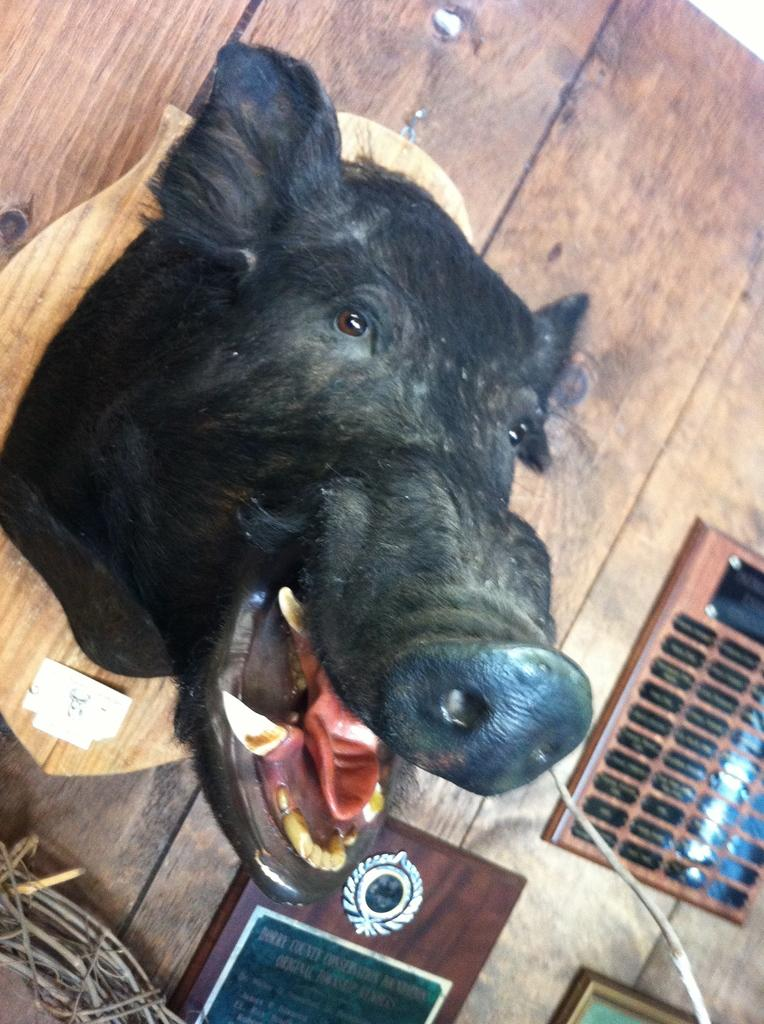What is the main subject of the image? The main subject of the image is a statue of a boar's head. Where is the statue placed in the image? The statue is kept on a wooden wall. What other object can be seen in the image? There is a shield in the image. How is the shield positioned in the image? The shield is kept on the ground. What type of pan is hanging from the boar's head in the image? There is no pan present in the image; it features a statue of a boar's head and a shield. Can you see any bats flying around the boar's head in the image? There are no bats present in the image; it only features a statue of a boar's head and a shield. 